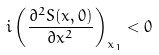<formula> <loc_0><loc_0><loc_500><loc_500>i \left ( \frac { \partial ^ { 2 } S ( x , 0 ) } { \partial x ^ { 2 } } \right ) _ { x _ { 1 } } < 0</formula> 